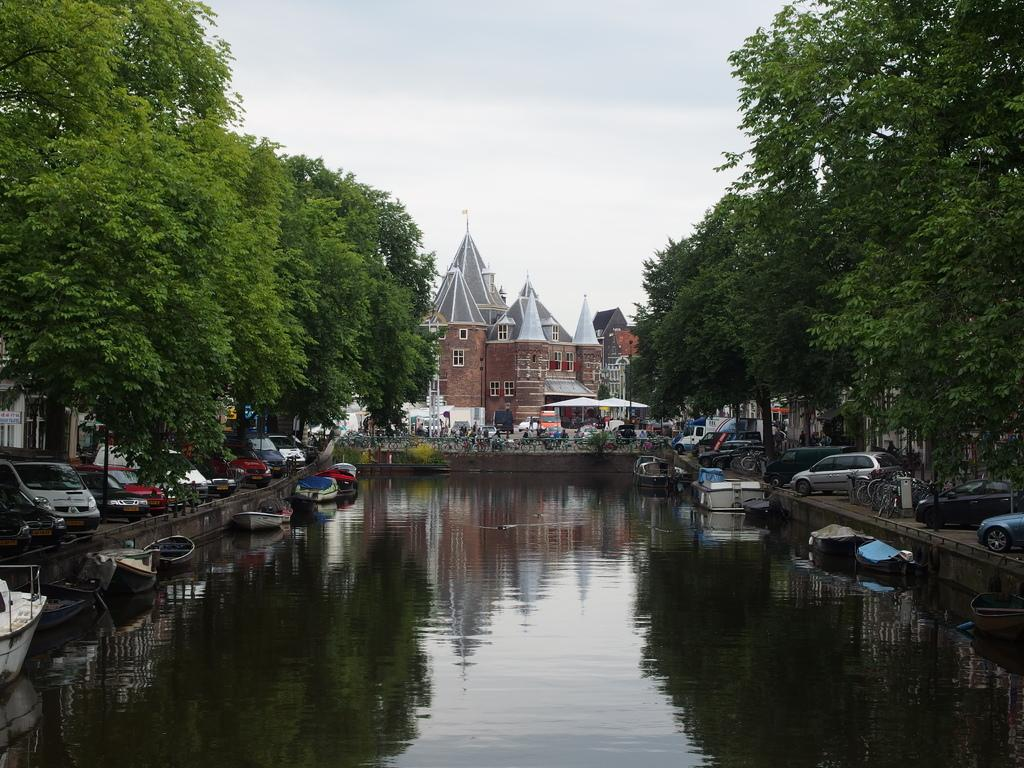What can be seen floating on the water in the image? There are several boats on the water in the image. What type of vehicles are parked on the road in the image? There are cars parked on the road in the image. What can be seen in the background of the image? There is a group of trees, a building, and a shed in the background, as well as the sky. What color are the eyes of the person driving the boat in the image? There are no people or eyes visible in the image; it only shows boats on the water, cars parked on the road, and various background elements. 